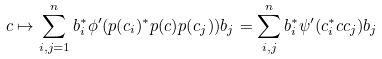<formula> <loc_0><loc_0><loc_500><loc_500>c \mapsto \sum _ { i , j = 1 } ^ { n } b _ { i } ^ { \ast } \phi ^ { \prime } ( p ( c _ { i } ) ^ { \ast } p ( c ) p ( c _ { j } ) ) b _ { j } = \sum _ { i , j } ^ { n } b _ { i } ^ { \ast } \psi ^ { \prime } ( c _ { i } ^ { \ast } c c _ { j } ) b _ { j }</formula> 